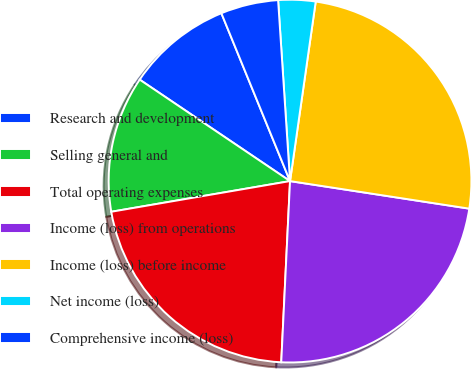Convert chart. <chart><loc_0><loc_0><loc_500><loc_500><pie_chart><fcel>Research and development<fcel>Selling general and<fcel>Total operating expenses<fcel>Income (loss) from operations<fcel>Income (loss) before income<fcel>Net income (loss)<fcel>Comprehensive income (loss)<nl><fcel>9.37%<fcel>12.15%<fcel>21.52%<fcel>23.34%<fcel>25.16%<fcel>3.31%<fcel>5.13%<nl></chart> 